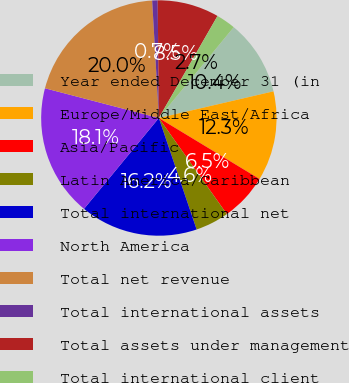Convert chart to OTSL. <chart><loc_0><loc_0><loc_500><loc_500><pie_chart><fcel>Year ended December 31 (in<fcel>Europe/Middle East/Africa<fcel>Asia/Pacific<fcel>Latin America/Caribbean<fcel>Total international net<fcel>North America<fcel>Total net revenue<fcel>Total international assets<fcel>Total assets under management<fcel>Total international client<nl><fcel>10.39%<fcel>12.31%<fcel>6.53%<fcel>4.6%<fcel>16.17%<fcel>18.1%<fcel>20.03%<fcel>0.75%<fcel>8.46%<fcel>2.67%<nl></chart> 